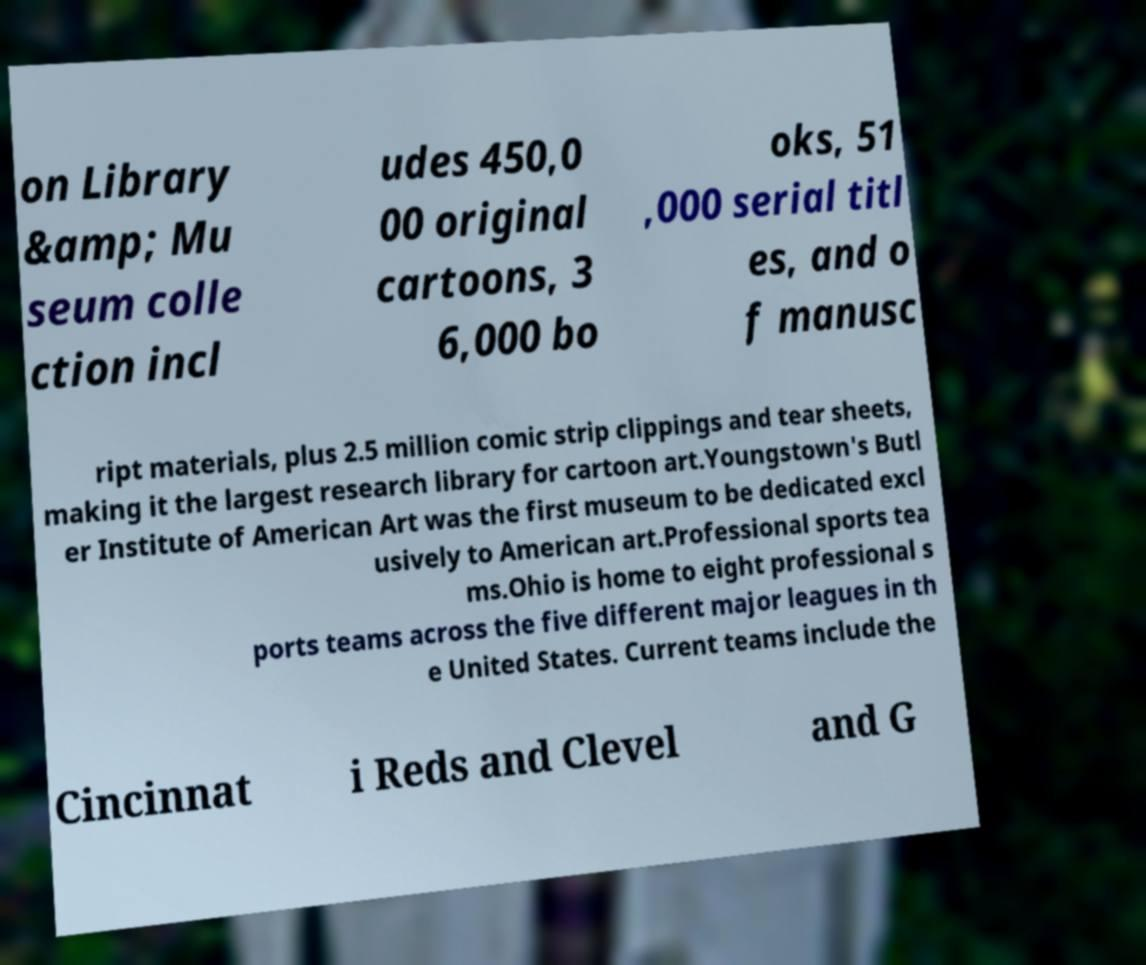Can you read and provide the text displayed in the image?This photo seems to have some interesting text. Can you extract and type it out for me? on Library &amp; Mu seum colle ction incl udes 450,0 00 original cartoons, 3 6,000 bo oks, 51 ,000 serial titl es, and o f manusc ript materials, plus 2.5 million comic strip clippings and tear sheets, making it the largest research library for cartoon art.Youngstown's Butl er Institute of American Art was the first museum to be dedicated excl usively to American art.Professional sports tea ms.Ohio is home to eight professional s ports teams across the five different major leagues in th e United States. Current teams include the Cincinnat i Reds and Clevel and G 